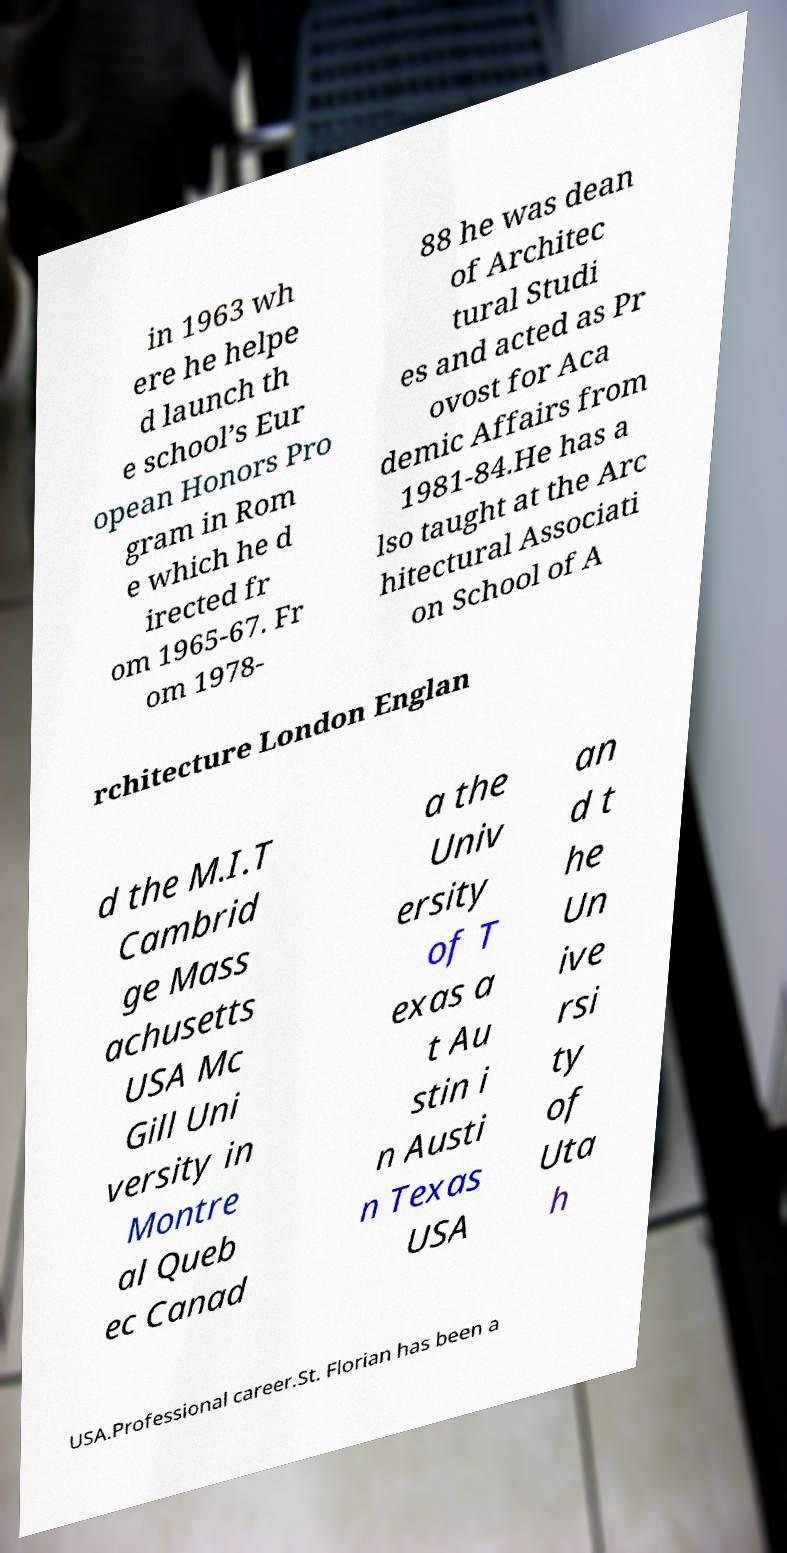For documentation purposes, I need the text within this image transcribed. Could you provide that? in 1963 wh ere he helpe d launch th e school’s Eur opean Honors Pro gram in Rom e which he d irected fr om 1965-67. Fr om 1978- 88 he was dean of Architec tural Studi es and acted as Pr ovost for Aca demic Affairs from 1981-84.He has a lso taught at the Arc hitectural Associati on School of A rchitecture London Englan d the M.I.T Cambrid ge Mass achusetts USA Mc Gill Uni versity in Montre al Queb ec Canad a the Univ ersity of T exas a t Au stin i n Austi n Texas USA an d t he Un ive rsi ty of Uta h USA.Professional career.St. Florian has been a 